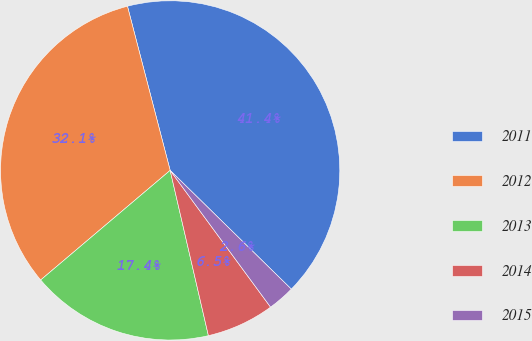<chart> <loc_0><loc_0><loc_500><loc_500><pie_chart><fcel>2011<fcel>2012<fcel>2013<fcel>2014<fcel>2015<nl><fcel>41.39%<fcel>32.13%<fcel>17.44%<fcel>6.46%<fcel>2.58%<nl></chart> 